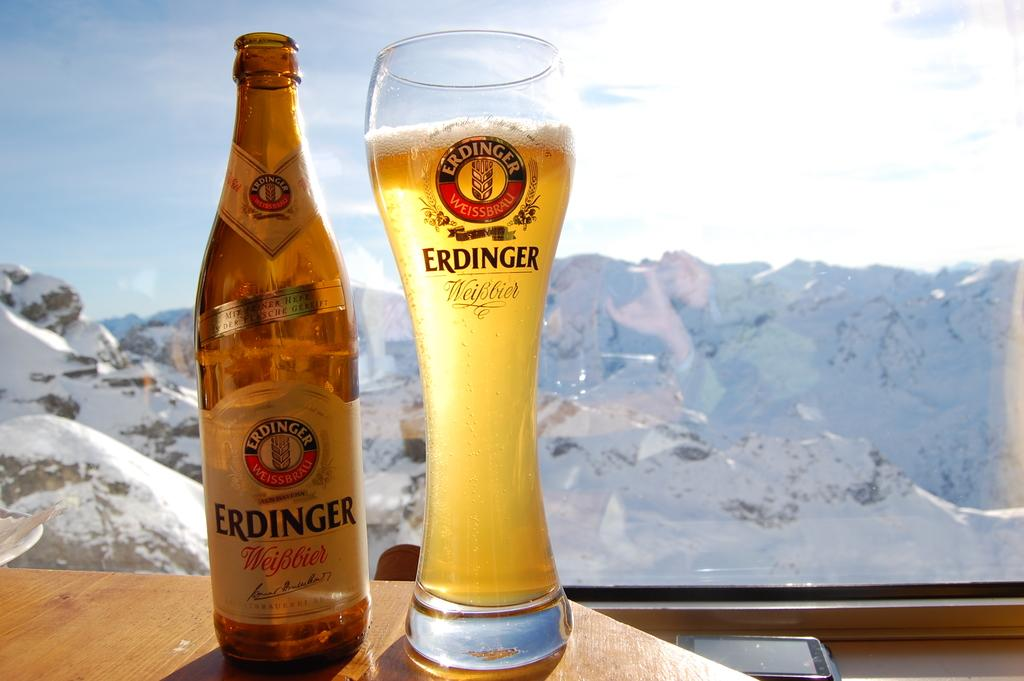What objects are on the table in the image? There is a bottle and a glass on a table in the image. What type of weather is depicted in the image? There is snow in the image, indicating cold weather. What other object can be seen in the image? There is a mobile in the image. How many girls are playing with the goat in the garden in the image? There are no girls, goat, or garden present in the image. 